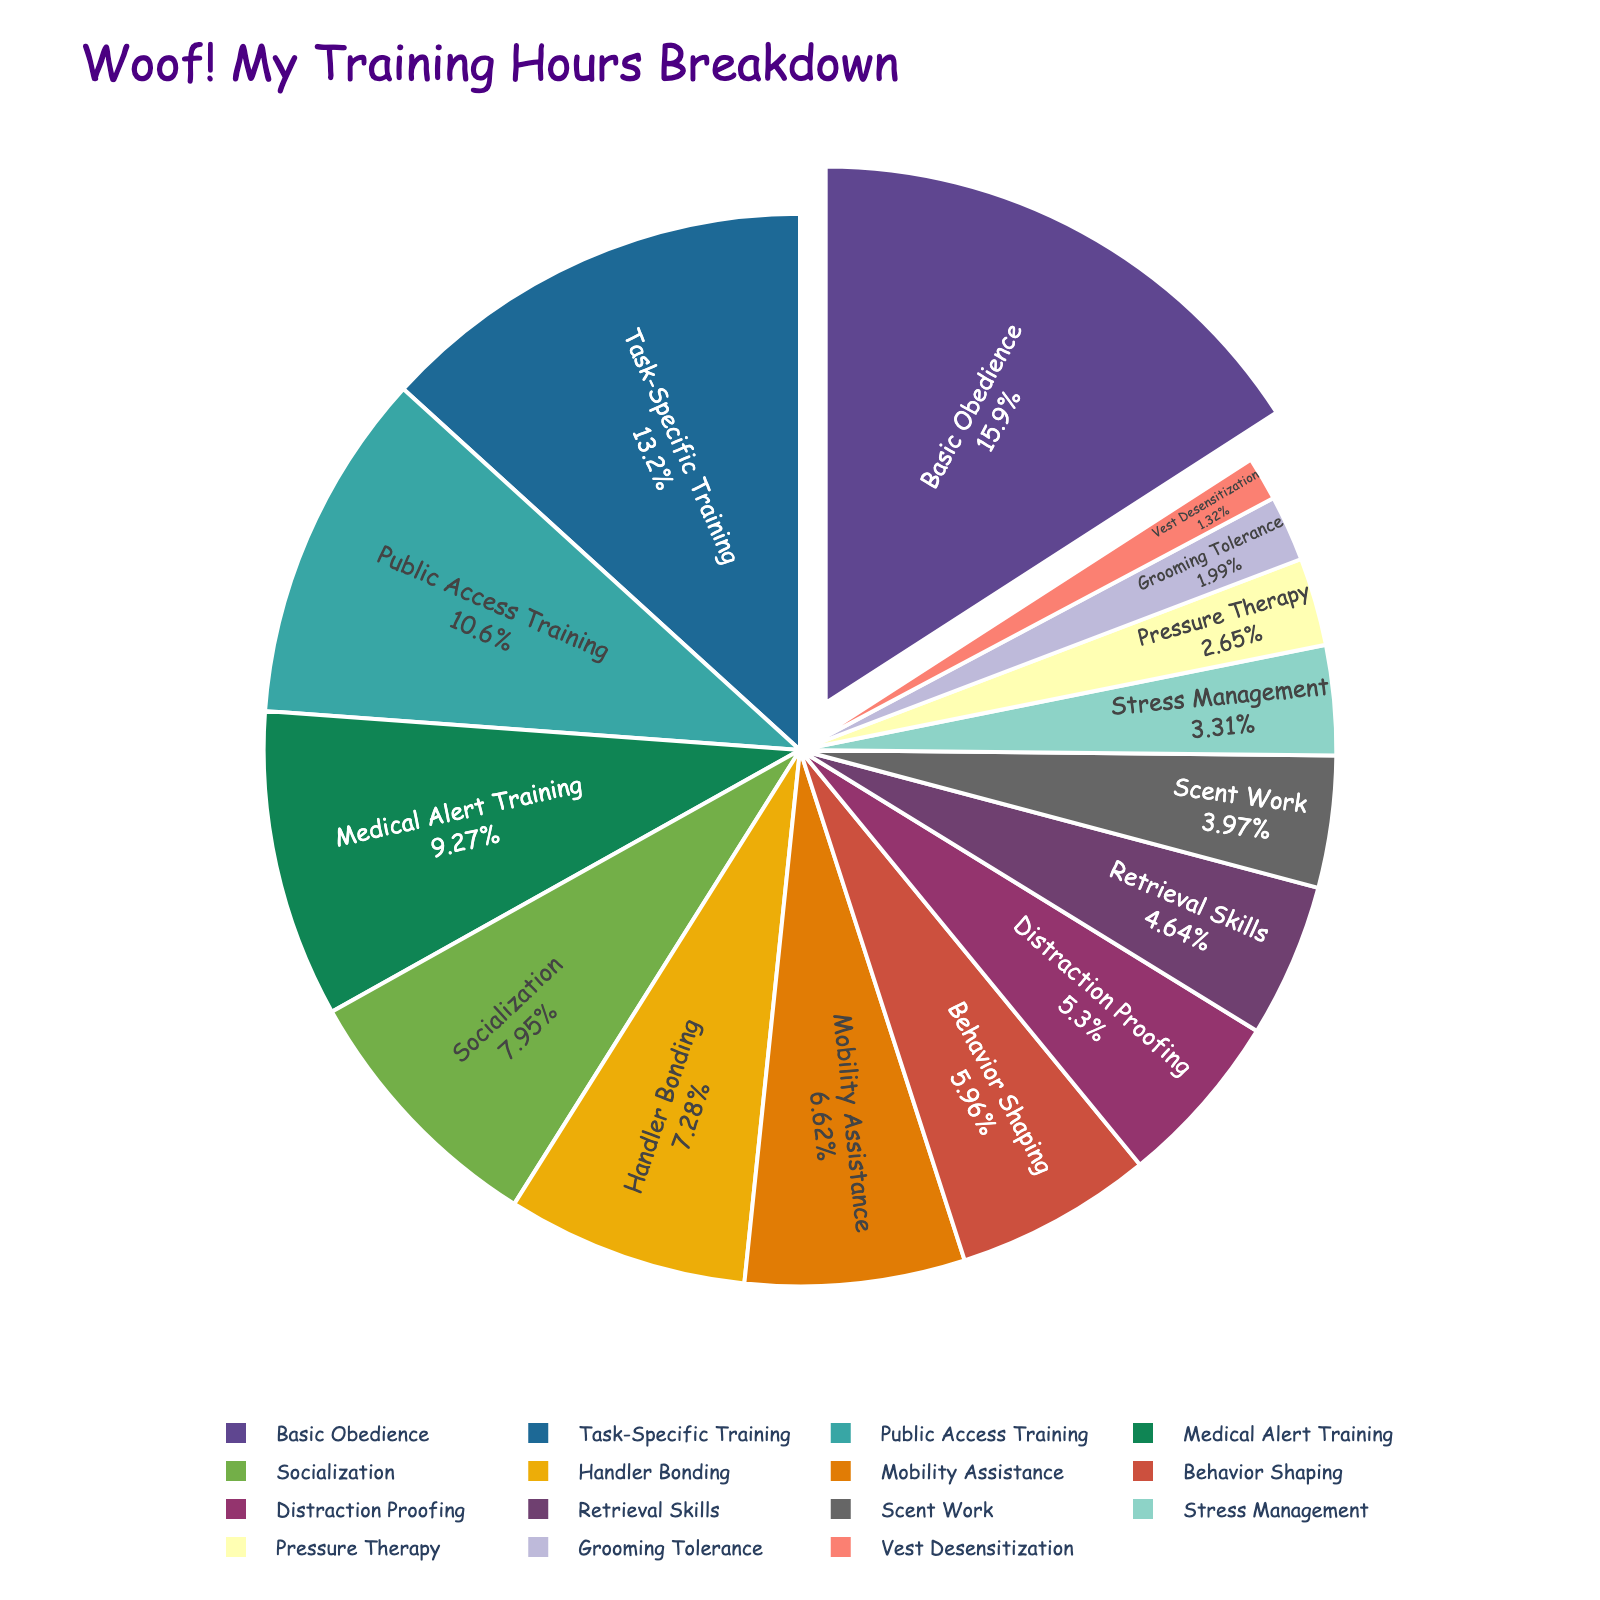What's the skill with the highest training hours? The pie chart prominently shows that "Basic Obedience" has the largest slice and is pulled out from the rest of the chart, indicating it takes up the most training hours.
Answer: Basic Obedience How many total hours are spent on Task-Specific Training and Medical Alert Training combined? Task-Specific Training has 100 hours, and Medical Alert Training has 70 hours. Summing them gives 100 + 70.
Answer: 170 Which skill takes up more training hours, Distraction Proofing or Scent Work? From the chart, Distraction Proofing has 40 hours, and Scent Work has 30 hours. 40 is more than 30.
Answer: Distraction Proofing What's the percentage of hours spent on Socialization training? By looking at the slice labeled "Socialization", the chart shows that it makes up 9.1% of the total training hours.
Answer: 9.1% Is Handler Bonding trained more or less than Mobility Assistance? From the chart, Handler Bonding has 55 hours, whereas Mobility Assistance has 50 hours. 55 is more than 50.
Answer: More What is the difference in training hours between Public Access Training and Retrieval Skills? Public Access Training has 80 hours, and Retrieval Skills has 35 hours. The difference is 80 - 35.
Answer: 45 What training skill takes up exactly 25 hours? From the chart, the slice labeled "Stress Management" shows it has exactly 25 hours.
Answer: Stress Management How do Grooming Tolerance hours compare to Vest Desensitization hours? Grooming Tolerance is 15 hours, and Vest Desensitization is 10 hours. 15 is more than 10.
Answer: Grooming Tolerance has more Which skill has a smaller percentage of hours, Pressure Therapy or Grooming Tolerance? Pressure Therapy has 20 hours, and Grooming Tolerance has 15 hours. Pressure Therapy's percentage is smaller in the chart when compared to Grooming Tolerance.
Answer: Grooming Tolerance has a smaller percentage What are the total number of hours if you add Handler Bonding, Behavior Shaping, and Public Access Training? Handler Bonding has 55 hours, Behavior Shaping has 45 hours, and Public Access Training has 80 hours. The sum is 55 + 45 + 80.
Answer: 180 